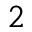<formula> <loc_0><loc_0><loc_500><loc_500>^ { 2 }</formula> 